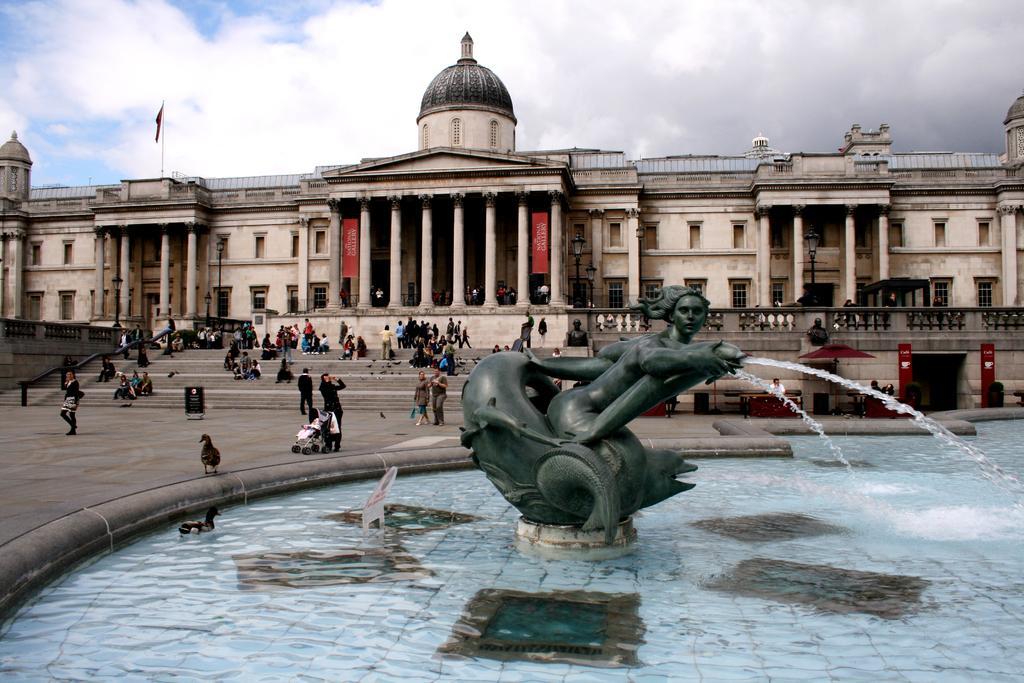Describe this image in one or two sentences. In the image we can see there is a fountain and there is a statue of mermaid. There is a pond and there is a duck swimming in the water. There is a duck and people standing on the ground. There are people sitting on the stairs and behind there is a building. There is a flag kept on the building and there is a cloudy sky. 